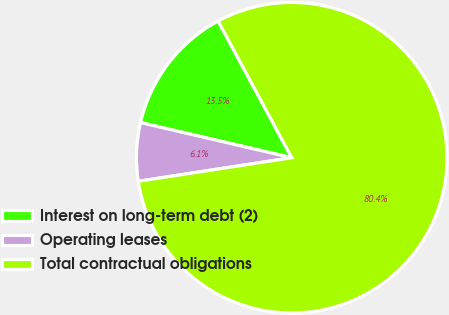Convert chart. <chart><loc_0><loc_0><loc_500><loc_500><pie_chart><fcel>Interest on long-term debt (2)<fcel>Operating leases<fcel>Total contractual obligations<nl><fcel>13.5%<fcel>6.06%<fcel>80.44%<nl></chart> 